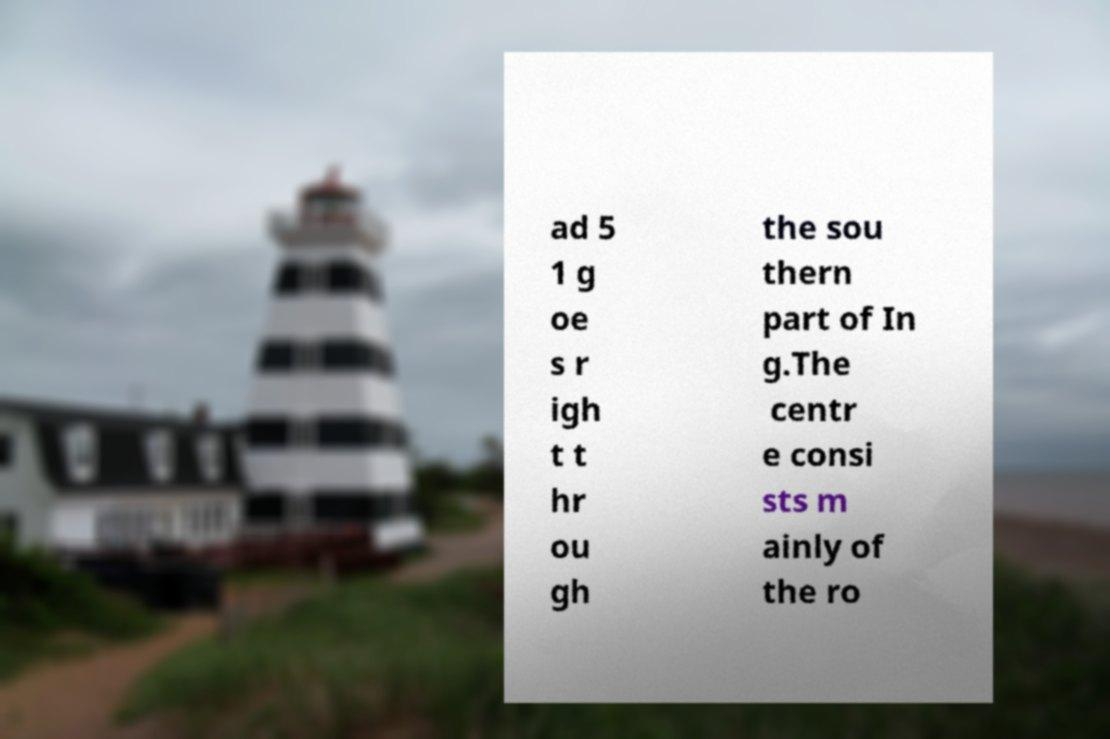What messages or text are displayed in this image? I need them in a readable, typed format. ad 5 1 g oe s r igh t t hr ou gh the sou thern part of In g.The centr e consi sts m ainly of the ro 